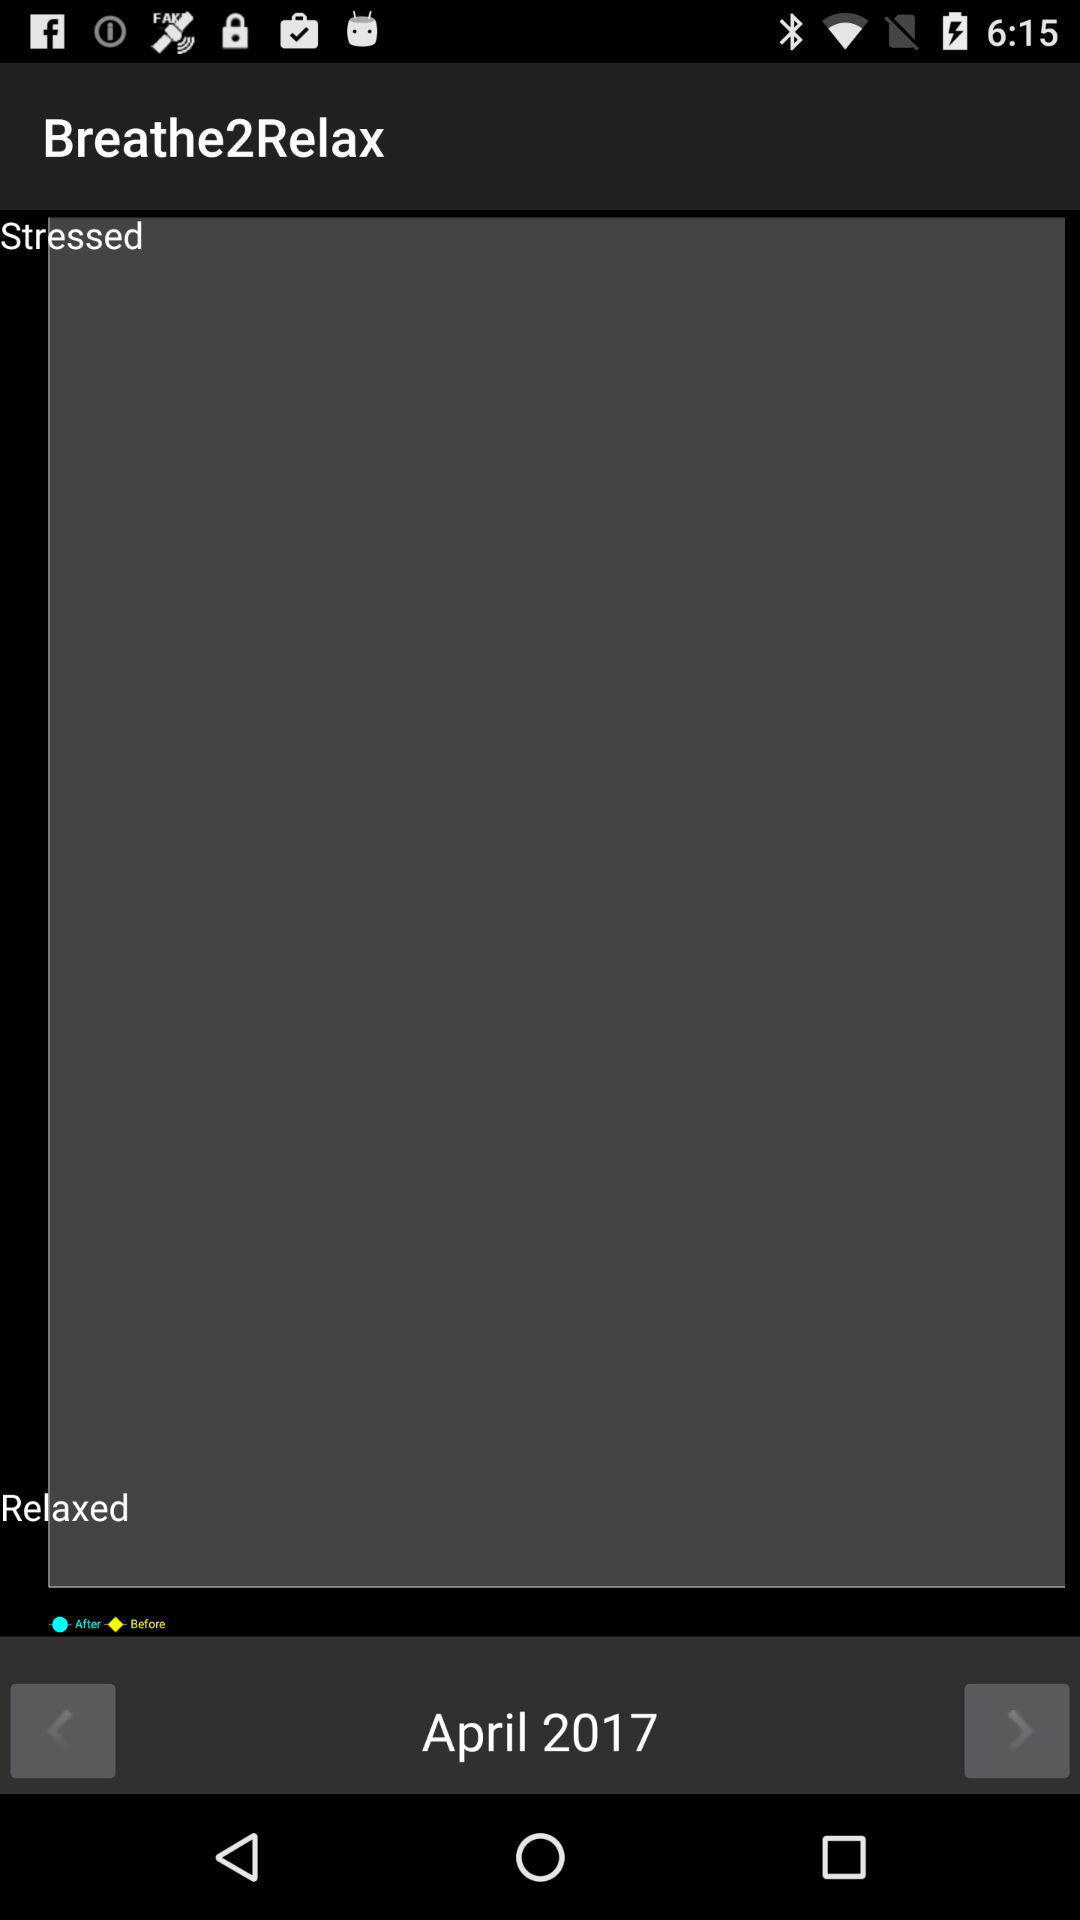What is the name of the application? The name of the application is "Breathe2Relax". 